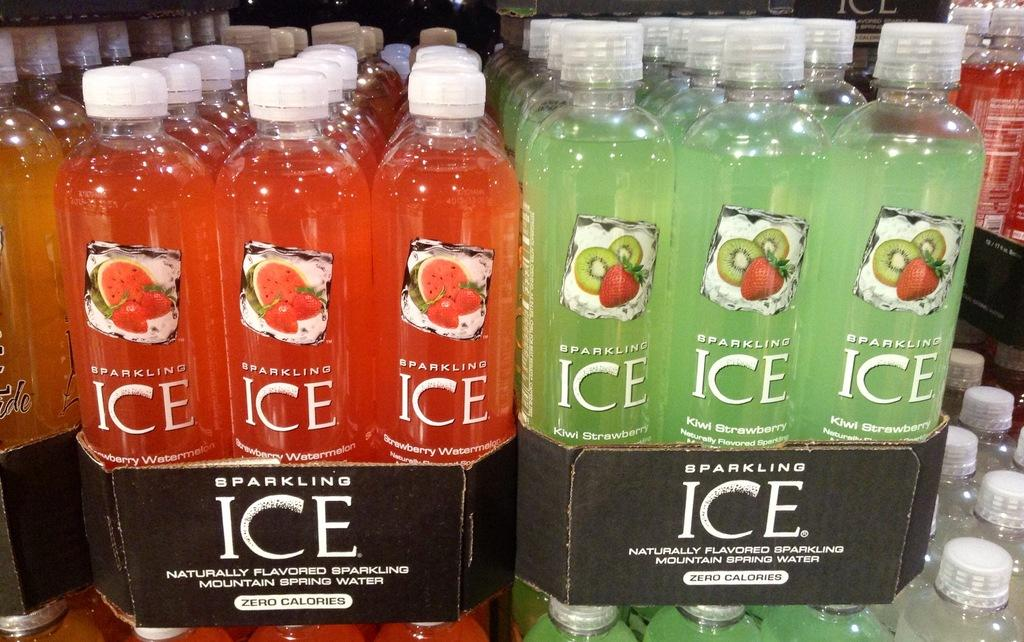How many bottles are present in the image? There are two different kinds of bottles in the image. What colors are the bottles? One bottle is red in color, and the other bottle is green in color. How many kittens are wearing jeans in the image? There are no kittens or jeans present in the image. What is the point of the bottles in the image? The purpose or point of the bottles in the image cannot be determined from the provided facts. 